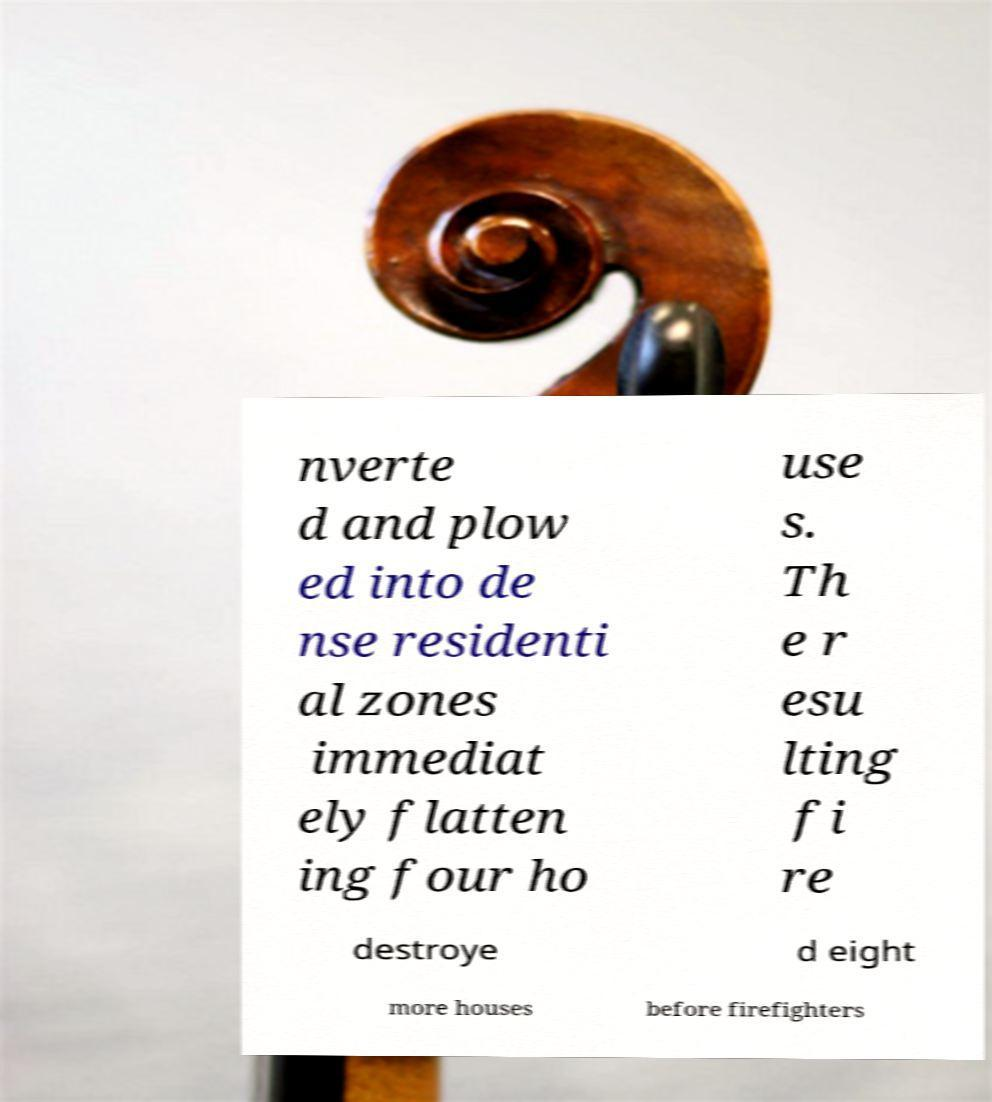Could you assist in decoding the text presented in this image and type it out clearly? nverte d and plow ed into de nse residenti al zones immediat ely flatten ing four ho use s. Th e r esu lting fi re destroye d eight more houses before firefighters 